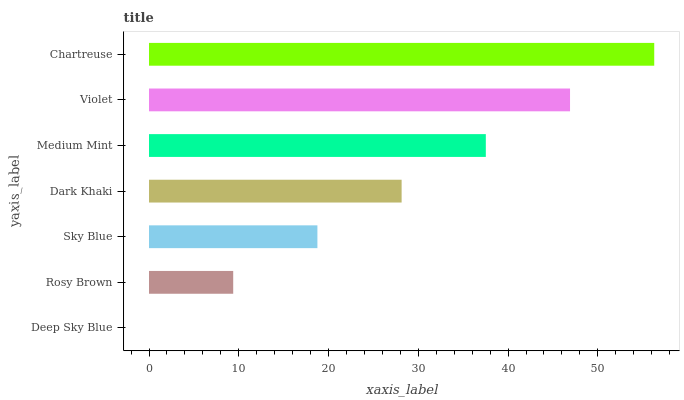Is Deep Sky Blue the minimum?
Answer yes or no. Yes. Is Chartreuse the maximum?
Answer yes or no. Yes. Is Rosy Brown the minimum?
Answer yes or no. No. Is Rosy Brown the maximum?
Answer yes or no. No. Is Rosy Brown greater than Deep Sky Blue?
Answer yes or no. Yes. Is Deep Sky Blue less than Rosy Brown?
Answer yes or no. Yes. Is Deep Sky Blue greater than Rosy Brown?
Answer yes or no. No. Is Rosy Brown less than Deep Sky Blue?
Answer yes or no. No. Is Dark Khaki the high median?
Answer yes or no. Yes. Is Dark Khaki the low median?
Answer yes or no. Yes. Is Sky Blue the high median?
Answer yes or no. No. Is Medium Mint the low median?
Answer yes or no. No. 